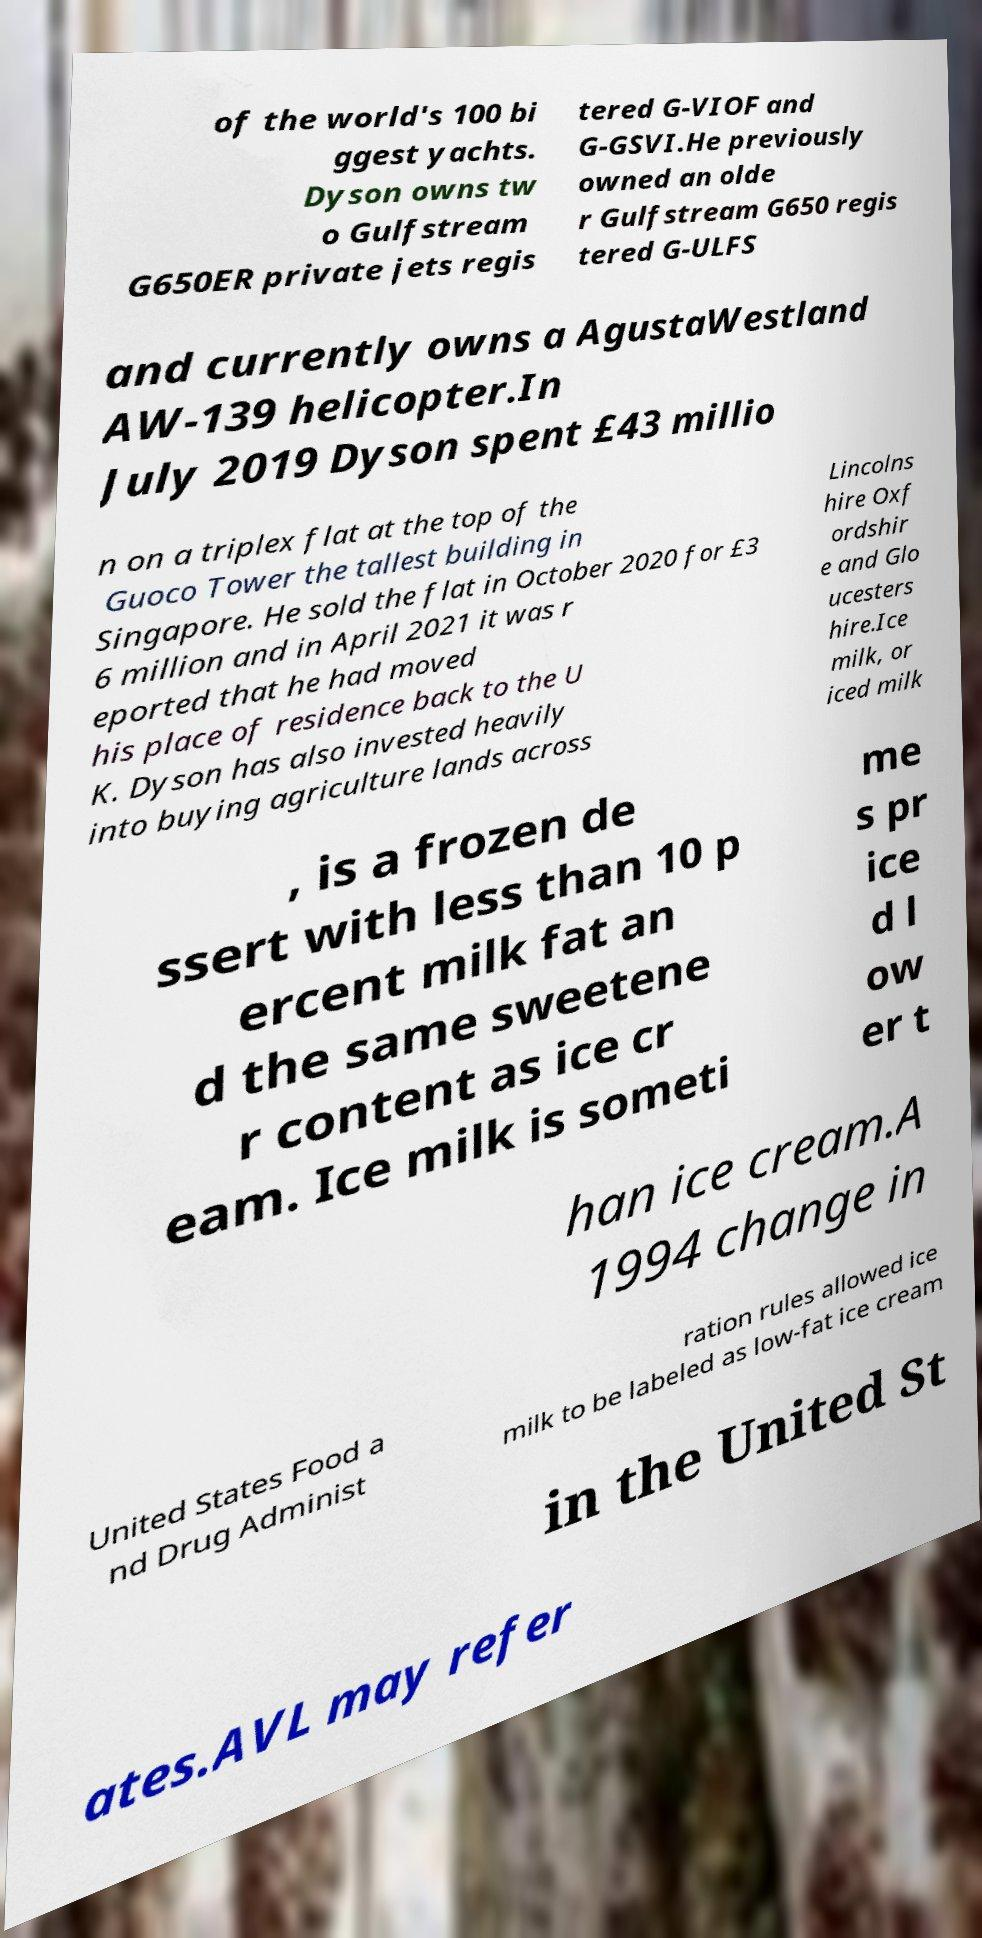For documentation purposes, I need the text within this image transcribed. Could you provide that? of the world's 100 bi ggest yachts. Dyson owns tw o Gulfstream G650ER private jets regis tered G-VIOF and G-GSVI.He previously owned an olde r Gulfstream G650 regis tered G-ULFS and currently owns a AgustaWestland AW-139 helicopter.In July 2019 Dyson spent £43 millio n on a triplex flat at the top of the Guoco Tower the tallest building in Singapore. He sold the flat in October 2020 for £3 6 million and in April 2021 it was r eported that he had moved his place of residence back to the U K. Dyson has also invested heavily into buying agriculture lands across Lincolns hire Oxf ordshir e and Glo ucesters hire.Ice milk, or iced milk , is a frozen de ssert with less than 10 p ercent milk fat an d the same sweetene r content as ice cr eam. Ice milk is someti me s pr ice d l ow er t han ice cream.A 1994 change in United States Food a nd Drug Administ ration rules allowed ice milk to be labeled as low-fat ice cream in the United St ates.AVL may refer 